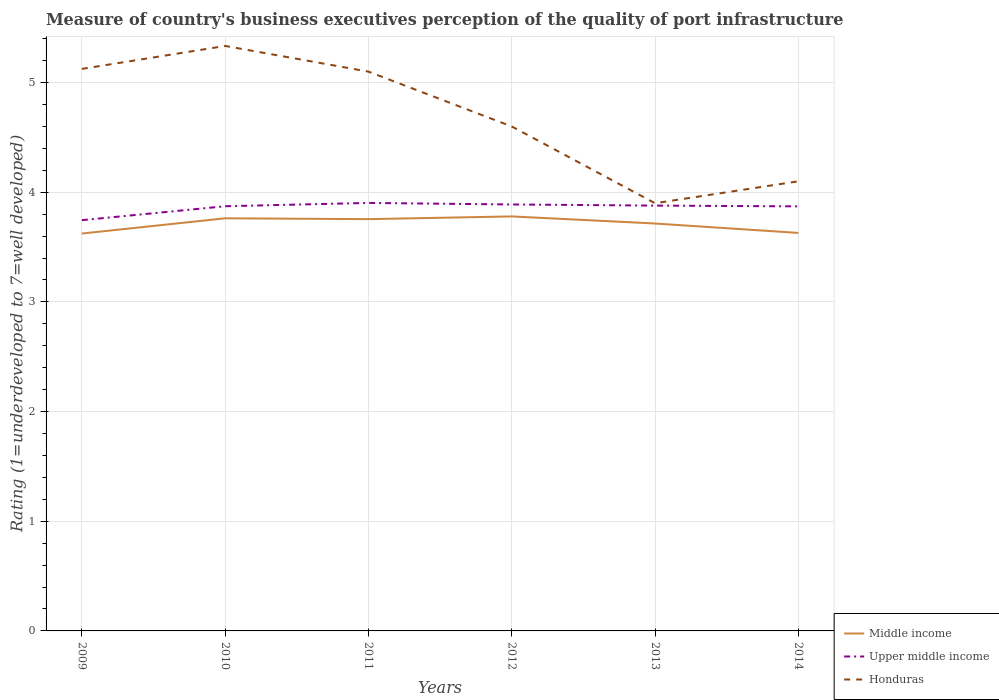Does the line corresponding to Middle income intersect with the line corresponding to Upper middle income?
Keep it short and to the point. No. Across all years, what is the maximum ratings of the quality of port infrastructure in Middle income?
Keep it short and to the point. 3.62. In which year was the ratings of the quality of port infrastructure in Upper middle income maximum?
Keep it short and to the point. 2009. What is the total ratings of the quality of port infrastructure in Upper middle income in the graph?
Offer a terse response. 0.02. What is the difference between the highest and the second highest ratings of the quality of port infrastructure in Honduras?
Your answer should be very brief. 1.43. How many years are there in the graph?
Provide a succinct answer. 6. Are the values on the major ticks of Y-axis written in scientific E-notation?
Keep it short and to the point. No. Where does the legend appear in the graph?
Give a very brief answer. Bottom right. What is the title of the graph?
Make the answer very short. Measure of country's business executives perception of the quality of port infrastructure. Does "El Salvador" appear as one of the legend labels in the graph?
Your answer should be compact. No. What is the label or title of the X-axis?
Provide a succinct answer. Years. What is the label or title of the Y-axis?
Provide a short and direct response. Rating (1=underdeveloped to 7=well developed). What is the Rating (1=underdeveloped to 7=well developed) in Middle income in 2009?
Offer a very short reply. 3.62. What is the Rating (1=underdeveloped to 7=well developed) of Upper middle income in 2009?
Ensure brevity in your answer.  3.75. What is the Rating (1=underdeveloped to 7=well developed) in Honduras in 2009?
Keep it short and to the point. 5.12. What is the Rating (1=underdeveloped to 7=well developed) of Middle income in 2010?
Make the answer very short. 3.76. What is the Rating (1=underdeveloped to 7=well developed) of Upper middle income in 2010?
Offer a very short reply. 3.87. What is the Rating (1=underdeveloped to 7=well developed) of Honduras in 2010?
Keep it short and to the point. 5.33. What is the Rating (1=underdeveloped to 7=well developed) of Middle income in 2011?
Provide a succinct answer. 3.75. What is the Rating (1=underdeveloped to 7=well developed) of Upper middle income in 2011?
Ensure brevity in your answer.  3.9. What is the Rating (1=underdeveloped to 7=well developed) of Middle income in 2012?
Your answer should be very brief. 3.78. What is the Rating (1=underdeveloped to 7=well developed) of Upper middle income in 2012?
Your answer should be compact. 3.89. What is the Rating (1=underdeveloped to 7=well developed) of Middle income in 2013?
Make the answer very short. 3.72. What is the Rating (1=underdeveloped to 7=well developed) in Upper middle income in 2013?
Offer a terse response. 3.88. What is the Rating (1=underdeveloped to 7=well developed) of Middle income in 2014?
Offer a terse response. 3.63. What is the Rating (1=underdeveloped to 7=well developed) in Upper middle income in 2014?
Offer a terse response. 3.87. Across all years, what is the maximum Rating (1=underdeveloped to 7=well developed) of Middle income?
Provide a succinct answer. 3.78. Across all years, what is the maximum Rating (1=underdeveloped to 7=well developed) in Upper middle income?
Offer a terse response. 3.9. Across all years, what is the maximum Rating (1=underdeveloped to 7=well developed) in Honduras?
Your answer should be compact. 5.33. Across all years, what is the minimum Rating (1=underdeveloped to 7=well developed) in Middle income?
Ensure brevity in your answer.  3.62. Across all years, what is the minimum Rating (1=underdeveloped to 7=well developed) of Upper middle income?
Make the answer very short. 3.75. Across all years, what is the minimum Rating (1=underdeveloped to 7=well developed) in Honduras?
Keep it short and to the point. 3.9. What is the total Rating (1=underdeveloped to 7=well developed) of Middle income in the graph?
Offer a terse response. 22.27. What is the total Rating (1=underdeveloped to 7=well developed) in Upper middle income in the graph?
Provide a short and direct response. 23.16. What is the total Rating (1=underdeveloped to 7=well developed) in Honduras in the graph?
Your answer should be compact. 28.16. What is the difference between the Rating (1=underdeveloped to 7=well developed) in Middle income in 2009 and that in 2010?
Your response must be concise. -0.14. What is the difference between the Rating (1=underdeveloped to 7=well developed) in Upper middle income in 2009 and that in 2010?
Your answer should be compact. -0.13. What is the difference between the Rating (1=underdeveloped to 7=well developed) in Honduras in 2009 and that in 2010?
Offer a terse response. -0.21. What is the difference between the Rating (1=underdeveloped to 7=well developed) of Middle income in 2009 and that in 2011?
Provide a short and direct response. -0.13. What is the difference between the Rating (1=underdeveloped to 7=well developed) in Upper middle income in 2009 and that in 2011?
Keep it short and to the point. -0.16. What is the difference between the Rating (1=underdeveloped to 7=well developed) in Honduras in 2009 and that in 2011?
Ensure brevity in your answer.  0.02. What is the difference between the Rating (1=underdeveloped to 7=well developed) of Middle income in 2009 and that in 2012?
Offer a very short reply. -0.16. What is the difference between the Rating (1=underdeveloped to 7=well developed) of Upper middle income in 2009 and that in 2012?
Offer a terse response. -0.14. What is the difference between the Rating (1=underdeveloped to 7=well developed) in Honduras in 2009 and that in 2012?
Your answer should be very brief. 0.52. What is the difference between the Rating (1=underdeveloped to 7=well developed) in Middle income in 2009 and that in 2013?
Make the answer very short. -0.09. What is the difference between the Rating (1=underdeveloped to 7=well developed) of Upper middle income in 2009 and that in 2013?
Your response must be concise. -0.13. What is the difference between the Rating (1=underdeveloped to 7=well developed) of Honduras in 2009 and that in 2013?
Keep it short and to the point. 1.22. What is the difference between the Rating (1=underdeveloped to 7=well developed) of Middle income in 2009 and that in 2014?
Give a very brief answer. -0.01. What is the difference between the Rating (1=underdeveloped to 7=well developed) of Upper middle income in 2009 and that in 2014?
Make the answer very short. -0.13. What is the difference between the Rating (1=underdeveloped to 7=well developed) in Honduras in 2009 and that in 2014?
Give a very brief answer. 1.02. What is the difference between the Rating (1=underdeveloped to 7=well developed) in Middle income in 2010 and that in 2011?
Your answer should be compact. 0.01. What is the difference between the Rating (1=underdeveloped to 7=well developed) of Upper middle income in 2010 and that in 2011?
Make the answer very short. -0.03. What is the difference between the Rating (1=underdeveloped to 7=well developed) of Honduras in 2010 and that in 2011?
Keep it short and to the point. 0.23. What is the difference between the Rating (1=underdeveloped to 7=well developed) of Middle income in 2010 and that in 2012?
Your response must be concise. -0.02. What is the difference between the Rating (1=underdeveloped to 7=well developed) in Upper middle income in 2010 and that in 2012?
Provide a succinct answer. -0.02. What is the difference between the Rating (1=underdeveloped to 7=well developed) in Honduras in 2010 and that in 2012?
Your answer should be compact. 0.73. What is the difference between the Rating (1=underdeveloped to 7=well developed) in Middle income in 2010 and that in 2013?
Ensure brevity in your answer.  0.05. What is the difference between the Rating (1=underdeveloped to 7=well developed) in Upper middle income in 2010 and that in 2013?
Make the answer very short. -0.01. What is the difference between the Rating (1=underdeveloped to 7=well developed) of Honduras in 2010 and that in 2013?
Your response must be concise. 1.43. What is the difference between the Rating (1=underdeveloped to 7=well developed) of Middle income in 2010 and that in 2014?
Provide a succinct answer. 0.13. What is the difference between the Rating (1=underdeveloped to 7=well developed) of Upper middle income in 2010 and that in 2014?
Give a very brief answer. 0. What is the difference between the Rating (1=underdeveloped to 7=well developed) in Honduras in 2010 and that in 2014?
Keep it short and to the point. 1.23. What is the difference between the Rating (1=underdeveloped to 7=well developed) in Middle income in 2011 and that in 2012?
Offer a very short reply. -0.02. What is the difference between the Rating (1=underdeveloped to 7=well developed) in Upper middle income in 2011 and that in 2012?
Provide a succinct answer. 0.01. What is the difference between the Rating (1=underdeveloped to 7=well developed) of Middle income in 2011 and that in 2013?
Your response must be concise. 0.04. What is the difference between the Rating (1=underdeveloped to 7=well developed) of Upper middle income in 2011 and that in 2013?
Your response must be concise. 0.02. What is the difference between the Rating (1=underdeveloped to 7=well developed) in Honduras in 2011 and that in 2013?
Provide a succinct answer. 1.2. What is the difference between the Rating (1=underdeveloped to 7=well developed) in Middle income in 2011 and that in 2014?
Give a very brief answer. 0.13. What is the difference between the Rating (1=underdeveloped to 7=well developed) in Upper middle income in 2011 and that in 2014?
Your answer should be very brief. 0.03. What is the difference between the Rating (1=underdeveloped to 7=well developed) in Honduras in 2011 and that in 2014?
Your answer should be compact. 1. What is the difference between the Rating (1=underdeveloped to 7=well developed) of Middle income in 2012 and that in 2013?
Provide a succinct answer. 0.06. What is the difference between the Rating (1=underdeveloped to 7=well developed) in Upper middle income in 2012 and that in 2013?
Offer a terse response. 0.01. What is the difference between the Rating (1=underdeveloped to 7=well developed) in Middle income in 2012 and that in 2014?
Provide a succinct answer. 0.15. What is the difference between the Rating (1=underdeveloped to 7=well developed) of Upper middle income in 2012 and that in 2014?
Provide a short and direct response. 0.02. What is the difference between the Rating (1=underdeveloped to 7=well developed) in Middle income in 2013 and that in 2014?
Give a very brief answer. 0.09. What is the difference between the Rating (1=underdeveloped to 7=well developed) in Upper middle income in 2013 and that in 2014?
Give a very brief answer. 0.01. What is the difference between the Rating (1=underdeveloped to 7=well developed) in Honduras in 2013 and that in 2014?
Offer a very short reply. -0.2. What is the difference between the Rating (1=underdeveloped to 7=well developed) of Middle income in 2009 and the Rating (1=underdeveloped to 7=well developed) of Upper middle income in 2010?
Keep it short and to the point. -0.25. What is the difference between the Rating (1=underdeveloped to 7=well developed) in Middle income in 2009 and the Rating (1=underdeveloped to 7=well developed) in Honduras in 2010?
Offer a terse response. -1.71. What is the difference between the Rating (1=underdeveloped to 7=well developed) of Upper middle income in 2009 and the Rating (1=underdeveloped to 7=well developed) of Honduras in 2010?
Make the answer very short. -1.59. What is the difference between the Rating (1=underdeveloped to 7=well developed) in Middle income in 2009 and the Rating (1=underdeveloped to 7=well developed) in Upper middle income in 2011?
Your answer should be very brief. -0.28. What is the difference between the Rating (1=underdeveloped to 7=well developed) of Middle income in 2009 and the Rating (1=underdeveloped to 7=well developed) of Honduras in 2011?
Your response must be concise. -1.48. What is the difference between the Rating (1=underdeveloped to 7=well developed) in Upper middle income in 2009 and the Rating (1=underdeveloped to 7=well developed) in Honduras in 2011?
Your response must be concise. -1.35. What is the difference between the Rating (1=underdeveloped to 7=well developed) in Middle income in 2009 and the Rating (1=underdeveloped to 7=well developed) in Upper middle income in 2012?
Provide a succinct answer. -0.27. What is the difference between the Rating (1=underdeveloped to 7=well developed) of Middle income in 2009 and the Rating (1=underdeveloped to 7=well developed) of Honduras in 2012?
Provide a short and direct response. -0.98. What is the difference between the Rating (1=underdeveloped to 7=well developed) in Upper middle income in 2009 and the Rating (1=underdeveloped to 7=well developed) in Honduras in 2012?
Your response must be concise. -0.85. What is the difference between the Rating (1=underdeveloped to 7=well developed) in Middle income in 2009 and the Rating (1=underdeveloped to 7=well developed) in Upper middle income in 2013?
Your answer should be compact. -0.25. What is the difference between the Rating (1=underdeveloped to 7=well developed) in Middle income in 2009 and the Rating (1=underdeveloped to 7=well developed) in Honduras in 2013?
Offer a very short reply. -0.28. What is the difference between the Rating (1=underdeveloped to 7=well developed) in Upper middle income in 2009 and the Rating (1=underdeveloped to 7=well developed) in Honduras in 2013?
Offer a very short reply. -0.15. What is the difference between the Rating (1=underdeveloped to 7=well developed) of Middle income in 2009 and the Rating (1=underdeveloped to 7=well developed) of Upper middle income in 2014?
Provide a short and direct response. -0.25. What is the difference between the Rating (1=underdeveloped to 7=well developed) in Middle income in 2009 and the Rating (1=underdeveloped to 7=well developed) in Honduras in 2014?
Ensure brevity in your answer.  -0.48. What is the difference between the Rating (1=underdeveloped to 7=well developed) of Upper middle income in 2009 and the Rating (1=underdeveloped to 7=well developed) of Honduras in 2014?
Give a very brief answer. -0.35. What is the difference between the Rating (1=underdeveloped to 7=well developed) of Middle income in 2010 and the Rating (1=underdeveloped to 7=well developed) of Upper middle income in 2011?
Keep it short and to the point. -0.14. What is the difference between the Rating (1=underdeveloped to 7=well developed) in Middle income in 2010 and the Rating (1=underdeveloped to 7=well developed) in Honduras in 2011?
Provide a succinct answer. -1.34. What is the difference between the Rating (1=underdeveloped to 7=well developed) of Upper middle income in 2010 and the Rating (1=underdeveloped to 7=well developed) of Honduras in 2011?
Give a very brief answer. -1.23. What is the difference between the Rating (1=underdeveloped to 7=well developed) in Middle income in 2010 and the Rating (1=underdeveloped to 7=well developed) in Upper middle income in 2012?
Provide a succinct answer. -0.13. What is the difference between the Rating (1=underdeveloped to 7=well developed) in Middle income in 2010 and the Rating (1=underdeveloped to 7=well developed) in Honduras in 2012?
Offer a terse response. -0.84. What is the difference between the Rating (1=underdeveloped to 7=well developed) in Upper middle income in 2010 and the Rating (1=underdeveloped to 7=well developed) in Honduras in 2012?
Provide a short and direct response. -0.73. What is the difference between the Rating (1=underdeveloped to 7=well developed) of Middle income in 2010 and the Rating (1=underdeveloped to 7=well developed) of Upper middle income in 2013?
Offer a very short reply. -0.12. What is the difference between the Rating (1=underdeveloped to 7=well developed) in Middle income in 2010 and the Rating (1=underdeveloped to 7=well developed) in Honduras in 2013?
Ensure brevity in your answer.  -0.14. What is the difference between the Rating (1=underdeveloped to 7=well developed) in Upper middle income in 2010 and the Rating (1=underdeveloped to 7=well developed) in Honduras in 2013?
Offer a very short reply. -0.03. What is the difference between the Rating (1=underdeveloped to 7=well developed) in Middle income in 2010 and the Rating (1=underdeveloped to 7=well developed) in Upper middle income in 2014?
Make the answer very short. -0.11. What is the difference between the Rating (1=underdeveloped to 7=well developed) in Middle income in 2010 and the Rating (1=underdeveloped to 7=well developed) in Honduras in 2014?
Keep it short and to the point. -0.34. What is the difference between the Rating (1=underdeveloped to 7=well developed) of Upper middle income in 2010 and the Rating (1=underdeveloped to 7=well developed) of Honduras in 2014?
Your answer should be compact. -0.23. What is the difference between the Rating (1=underdeveloped to 7=well developed) of Middle income in 2011 and the Rating (1=underdeveloped to 7=well developed) of Upper middle income in 2012?
Your answer should be very brief. -0.13. What is the difference between the Rating (1=underdeveloped to 7=well developed) in Middle income in 2011 and the Rating (1=underdeveloped to 7=well developed) in Honduras in 2012?
Your answer should be compact. -0.85. What is the difference between the Rating (1=underdeveloped to 7=well developed) of Upper middle income in 2011 and the Rating (1=underdeveloped to 7=well developed) of Honduras in 2012?
Keep it short and to the point. -0.7. What is the difference between the Rating (1=underdeveloped to 7=well developed) of Middle income in 2011 and the Rating (1=underdeveloped to 7=well developed) of Upper middle income in 2013?
Offer a terse response. -0.12. What is the difference between the Rating (1=underdeveloped to 7=well developed) in Middle income in 2011 and the Rating (1=underdeveloped to 7=well developed) in Honduras in 2013?
Offer a terse response. -0.15. What is the difference between the Rating (1=underdeveloped to 7=well developed) in Upper middle income in 2011 and the Rating (1=underdeveloped to 7=well developed) in Honduras in 2013?
Keep it short and to the point. 0. What is the difference between the Rating (1=underdeveloped to 7=well developed) in Middle income in 2011 and the Rating (1=underdeveloped to 7=well developed) in Upper middle income in 2014?
Your answer should be very brief. -0.12. What is the difference between the Rating (1=underdeveloped to 7=well developed) of Middle income in 2011 and the Rating (1=underdeveloped to 7=well developed) of Honduras in 2014?
Offer a terse response. -0.35. What is the difference between the Rating (1=underdeveloped to 7=well developed) in Upper middle income in 2011 and the Rating (1=underdeveloped to 7=well developed) in Honduras in 2014?
Your answer should be very brief. -0.2. What is the difference between the Rating (1=underdeveloped to 7=well developed) of Middle income in 2012 and the Rating (1=underdeveloped to 7=well developed) of Upper middle income in 2013?
Your answer should be very brief. -0.1. What is the difference between the Rating (1=underdeveloped to 7=well developed) of Middle income in 2012 and the Rating (1=underdeveloped to 7=well developed) of Honduras in 2013?
Keep it short and to the point. -0.12. What is the difference between the Rating (1=underdeveloped to 7=well developed) of Upper middle income in 2012 and the Rating (1=underdeveloped to 7=well developed) of Honduras in 2013?
Your response must be concise. -0.01. What is the difference between the Rating (1=underdeveloped to 7=well developed) of Middle income in 2012 and the Rating (1=underdeveloped to 7=well developed) of Upper middle income in 2014?
Make the answer very short. -0.09. What is the difference between the Rating (1=underdeveloped to 7=well developed) in Middle income in 2012 and the Rating (1=underdeveloped to 7=well developed) in Honduras in 2014?
Keep it short and to the point. -0.32. What is the difference between the Rating (1=underdeveloped to 7=well developed) in Upper middle income in 2012 and the Rating (1=underdeveloped to 7=well developed) in Honduras in 2014?
Your answer should be very brief. -0.21. What is the difference between the Rating (1=underdeveloped to 7=well developed) of Middle income in 2013 and the Rating (1=underdeveloped to 7=well developed) of Upper middle income in 2014?
Provide a succinct answer. -0.16. What is the difference between the Rating (1=underdeveloped to 7=well developed) of Middle income in 2013 and the Rating (1=underdeveloped to 7=well developed) of Honduras in 2014?
Your response must be concise. -0.38. What is the difference between the Rating (1=underdeveloped to 7=well developed) in Upper middle income in 2013 and the Rating (1=underdeveloped to 7=well developed) in Honduras in 2014?
Keep it short and to the point. -0.22. What is the average Rating (1=underdeveloped to 7=well developed) of Middle income per year?
Give a very brief answer. 3.71. What is the average Rating (1=underdeveloped to 7=well developed) of Upper middle income per year?
Offer a terse response. 3.86. What is the average Rating (1=underdeveloped to 7=well developed) of Honduras per year?
Provide a short and direct response. 4.69. In the year 2009, what is the difference between the Rating (1=underdeveloped to 7=well developed) in Middle income and Rating (1=underdeveloped to 7=well developed) in Upper middle income?
Your response must be concise. -0.12. In the year 2009, what is the difference between the Rating (1=underdeveloped to 7=well developed) of Middle income and Rating (1=underdeveloped to 7=well developed) of Honduras?
Ensure brevity in your answer.  -1.5. In the year 2009, what is the difference between the Rating (1=underdeveloped to 7=well developed) in Upper middle income and Rating (1=underdeveloped to 7=well developed) in Honduras?
Offer a terse response. -1.38. In the year 2010, what is the difference between the Rating (1=underdeveloped to 7=well developed) of Middle income and Rating (1=underdeveloped to 7=well developed) of Upper middle income?
Ensure brevity in your answer.  -0.11. In the year 2010, what is the difference between the Rating (1=underdeveloped to 7=well developed) in Middle income and Rating (1=underdeveloped to 7=well developed) in Honduras?
Your answer should be compact. -1.57. In the year 2010, what is the difference between the Rating (1=underdeveloped to 7=well developed) in Upper middle income and Rating (1=underdeveloped to 7=well developed) in Honduras?
Your answer should be very brief. -1.46. In the year 2011, what is the difference between the Rating (1=underdeveloped to 7=well developed) of Middle income and Rating (1=underdeveloped to 7=well developed) of Upper middle income?
Provide a short and direct response. -0.15. In the year 2011, what is the difference between the Rating (1=underdeveloped to 7=well developed) of Middle income and Rating (1=underdeveloped to 7=well developed) of Honduras?
Your answer should be compact. -1.35. In the year 2011, what is the difference between the Rating (1=underdeveloped to 7=well developed) of Upper middle income and Rating (1=underdeveloped to 7=well developed) of Honduras?
Your response must be concise. -1.2. In the year 2012, what is the difference between the Rating (1=underdeveloped to 7=well developed) of Middle income and Rating (1=underdeveloped to 7=well developed) of Upper middle income?
Make the answer very short. -0.11. In the year 2012, what is the difference between the Rating (1=underdeveloped to 7=well developed) in Middle income and Rating (1=underdeveloped to 7=well developed) in Honduras?
Offer a terse response. -0.82. In the year 2012, what is the difference between the Rating (1=underdeveloped to 7=well developed) in Upper middle income and Rating (1=underdeveloped to 7=well developed) in Honduras?
Provide a succinct answer. -0.71. In the year 2013, what is the difference between the Rating (1=underdeveloped to 7=well developed) in Middle income and Rating (1=underdeveloped to 7=well developed) in Upper middle income?
Your answer should be very brief. -0.16. In the year 2013, what is the difference between the Rating (1=underdeveloped to 7=well developed) in Middle income and Rating (1=underdeveloped to 7=well developed) in Honduras?
Provide a succinct answer. -0.18. In the year 2013, what is the difference between the Rating (1=underdeveloped to 7=well developed) in Upper middle income and Rating (1=underdeveloped to 7=well developed) in Honduras?
Your answer should be very brief. -0.02. In the year 2014, what is the difference between the Rating (1=underdeveloped to 7=well developed) in Middle income and Rating (1=underdeveloped to 7=well developed) in Upper middle income?
Give a very brief answer. -0.24. In the year 2014, what is the difference between the Rating (1=underdeveloped to 7=well developed) in Middle income and Rating (1=underdeveloped to 7=well developed) in Honduras?
Make the answer very short. -0.47. In the year 2014, what is the difference between the Rating (1=underdeveloped to 7=well developed) in Upper middle income and Rating (1=underdeveloped to 7=well developed) in Honduras?
Offer a very short reply. -0.23. What is the ratio of the Rating (1=underdeveloped to 7=well developed) of Middle income in 2009 to that in 2010?
Provide a succinct answer. 0.96. What is the ratio of the Rating (1=underdeveloped to 7=well developed) of Upper middle income in 2009 to that in 2010?
Provide a short and direct response. 0.97. What is the ratio of the Rating (1=underdeveloped to 7=well developed) in Honduras in 2009 to that in 2010?
Keep it short and to the point. 0.96. What is the ratio of the Rating (1=underdeveloped to 7=well developed) of Middle income in 2009 to that in 2011?
Offer a very short reply. 0.96. What is the ratio of the Rating (1=underdeveloped to 7=well developed) in Upper middle income in 2009 to that in 2011?
Your answer should be very brief. 0.96. What is the ratio of the Rating (1=underdeveloped to 7=well developed) in Honduras in 2009 to that in 2011?
Offer a very short reply. 1. What is the ratio of the Rating (1=underdeveloped to 7=well developed) of Middle income in 2009 to that in 2012?
Keep it short and to the point. 0.96. What is the ratio of the Rating (1=underdeveloped to 7=well developed) of Upper middle income in 2009 to that in 2012?
Give a very brief answer. 0.96. What is the ratio of the Rating (1=underdeveloped to 7=well developed) of Honduras in 2009 to that in 2012?
Your answer should be very brief. 1.11. What is the ratio of the Rating (1=underdeveloped to 7=well developed) in Middle income in 2009 to that in 2013?
Offer a very short reply. 0.98. What is the ratio of the Rating (1=underdeveloped to 7=well developed) in Upper middle income in 2009 to that in 2013?
Provide a short and direct response. 0.97. What is the ratio of the Rating (1=underdeveloped to 7=well developed) in Honduras in 2009 to that in 2013?
Provide a short and direct response. 1.31. What is the ratio of the Rating (1=underdeveloped to 7=well developed) in Upper middle income in 2009 to that in 2014?
Your response must be concise. 0.97. What is the ratio of the Rating (1=underdeveloped to 7=well developed) of Honduras in 2009 to that in 2014?
Offer a terse response. 1.25. What is the ratio of the Rating (1=underdeveloped to 7=well developed) in Honduras in 2010 to that in 2011?
Your response must be concise. 1.05. What is the ratio of the Rating (1=underdeveloped to 7=well developed) in Middle income in 2010 to that in 2012?
Make the answer very short. 1. What is the ratio of the Rating (1=underdeveloped to 7=well developed) in Upper middle income in 2010 to that in 2012?
Offer a very short reply. 1. What is the ratio of the Rating (1=underdeveloped to 7=well developed) of Honduras in 2010 to that in 2012?
Provide a succinct answer. 1.16. What is the ratio of the Rating (1=underdeveloped to 7=well developed) in Middle income in 2010 to that in 2013?
Make the answer very short. 1.01. What is the ratio of the Rating (1=underdeveloped to 7=well developed) in Honduras in 2010 to that in 2013?
Provide a succinct answer. 1.37. What is the ratio of the Rating (1=underdeveloped to 7=well developed) of Middle income in 2010 to that in 2014?
Your answer should be very brief. 1.04. What is the ratio of the Rating (1=underdeveloped to 7=well developed) in Upper middle income in 2010 to that in 2014?
Your answer should be compact. 1. What is the ratio of the Rating (1=underdeveloped to 7=well developed) in Honduras in 2010 to that in 2014?
Your answer should be compact. 1.3. What is the ratio of the Rating (1=underdeveloped to 7=well developed) in Honduras in 2011 to that in 2012?
Offer a terse response. 1.11. What is the ratio of the Rating (1=underdeveloped to 7=well developed) in Middle income in 2011 to that in 2013?
Your answer should be compact. 1.01. What is the ratio of the Rating (1=underdeveloped to 7=well developed) in Honduras in 2011 to that in 2013?
Your response must be concise. 1.31. What is the ratio of the Rating (1=underdeveloped to 7=well developed) of Middle income in 2011 to that in 2014?
Offer a very short reply. 1.03. What is the ratio of the Rating (1=underdeveloped to 7=well developed) of Honduras in 2011 to that in 2014?
Your answer should be compact. 1.24. What is the ratio of the Rating (1=underdeveloped to 7=well developed) of Middle income in 2012 to that in 2013?
Offer a terse response. 1.02. What is the ratio of the Rating (1=underdeveloped to 7=well developed) of Honduras in 2012 to that in 2013?
Give a very brief answer. 1.18. What is the ratio of the Rating (1=underdeveloped to 7=well developed) of Middle income in 2012 to that in 2014?
Your answer should be very brief. 1.04. What is the ratio of the Rating (1=underdeveloped to 7=well developed) of Honduras in 2012 to that in 2014?
Your response must be concise. 1.12. What is the ratio of the Rating (1=underdeveloped to 7=well developed) in Middle income in 2013 to that in 2014?
Keep it short and to the point. 1.02. What is the ratio of the Rating (1=underdeveloped to 7=well developed) in Honduras in 2013 to that in 2014?
Provide a short and direct response. 0.95. What is the difference between the highest and the second highest Rating (1=underdeveloped to 7=well developed) of Middle income?
Your answer should be very brief. 0.02. What is the difference between the highest and the second highest Rating (1=underdeveloped to 7=well developed) in Upper middle income?
Ensure brevity in your answer.  0.01. What is the difference between the highest and the second highest Rating (1=underdeveloped to 7=well developed) in Honduras?
Provide a short and direct response. 0.21. What is the difference between the highest and the lowest Rating (1=underdeveloped to 7=well developed) in Middle income?
Your response must be concise. 0.16. What is the difference between the highest and the lowest Rating (1=underdeveloped to 7=well developed) in Upper middle income?
Provide a short and direct response. 0.16. What is the difference between the highest and the lowest Rating (1=underdeveloped to 7=well developed) of Honduras?
Provide a succinct answer. 1.43. 